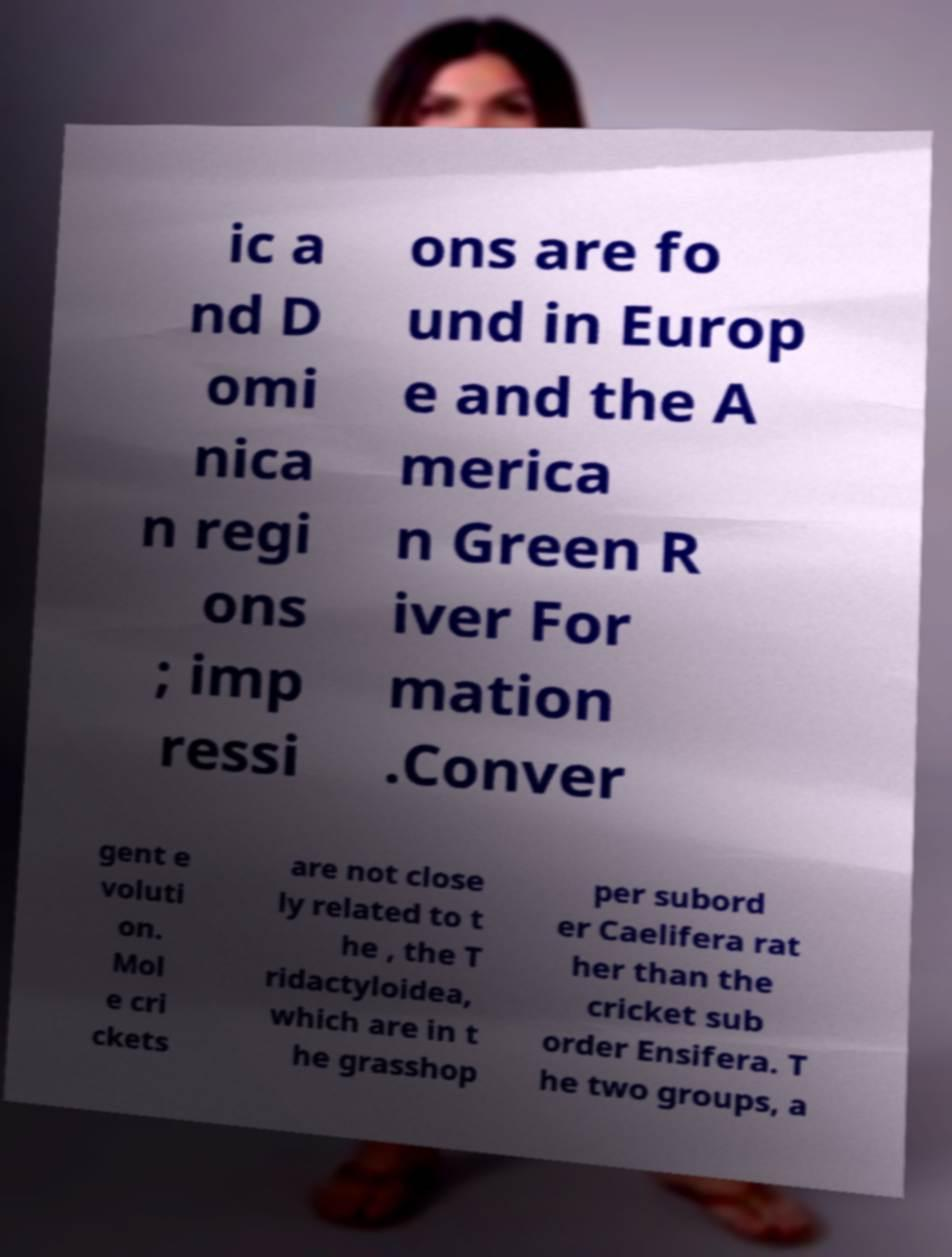Please read and relay the text visible in this image. What does it say? ic a nd D omi nica n regi ons ; imp ressi ons are fo und in Europ e and the A merica n Green R iver For mation .Conver gent e voluti on. Mol e cri ckets are not close ly related to t he , the T ridactyloidea, which are in t he grasshop per subord er Caelifera rat her than the cricket sub order Ensifera. T he two groups, a 